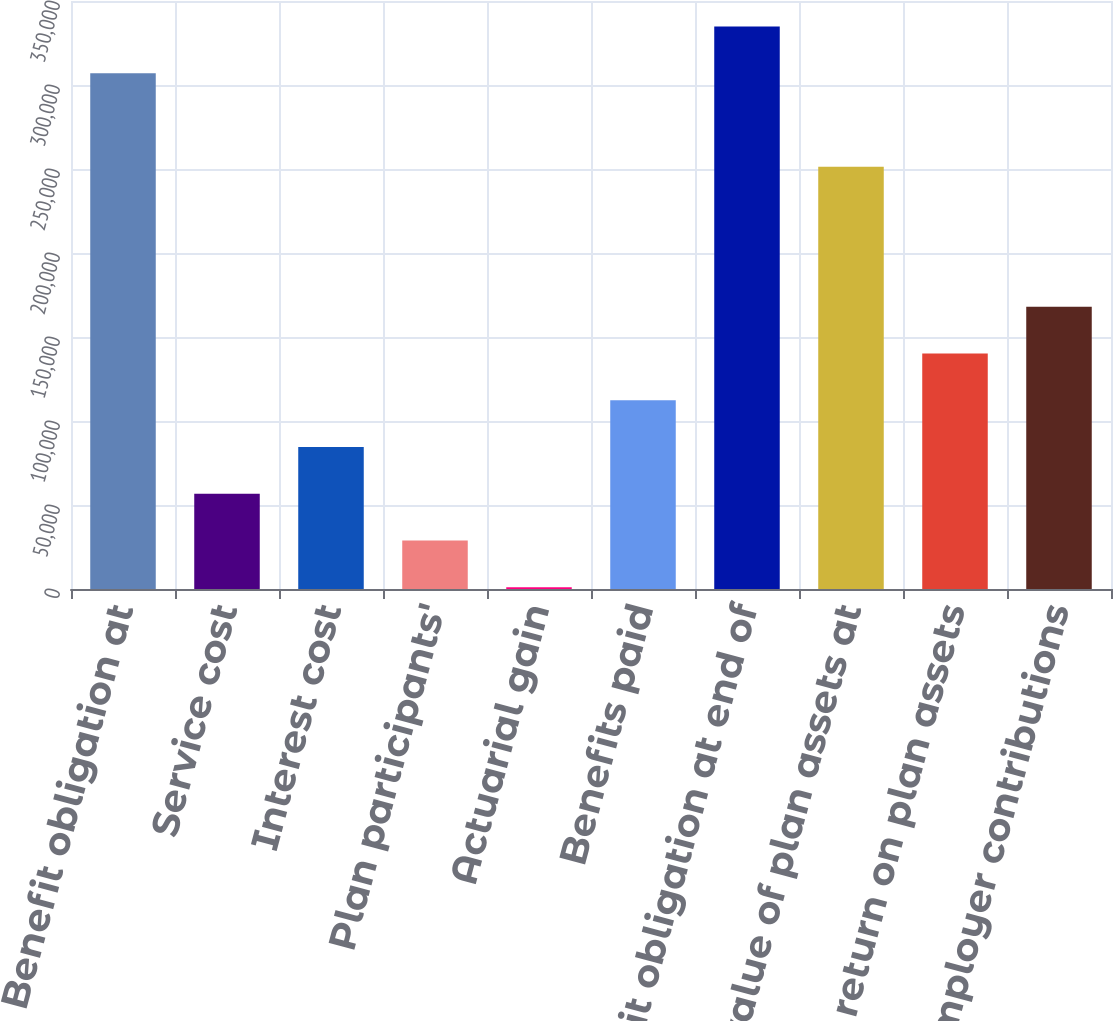Convert chart. <chart><loc_0><loc_0><loc_500><loc_500><bar_chart><fcel>Benefit obligation at<fcel>Service cost<fcel>Interest cost<fcel>Plan participants'<fcel>Actuarial gain<fcel>Benefits paid<fcel>Benefit obligation at end of<fcel>Fair value of plan assets at<fcel>Actual return on plan assets<fcel>Employer contributions<nl><fcel>307039<fcel>56686<fcel>84503<fcel>28869<fcel>1052<fcel>112320<fcel>334856<fcel>251405<fcel>140137<fcel>167954<nl></chart> 